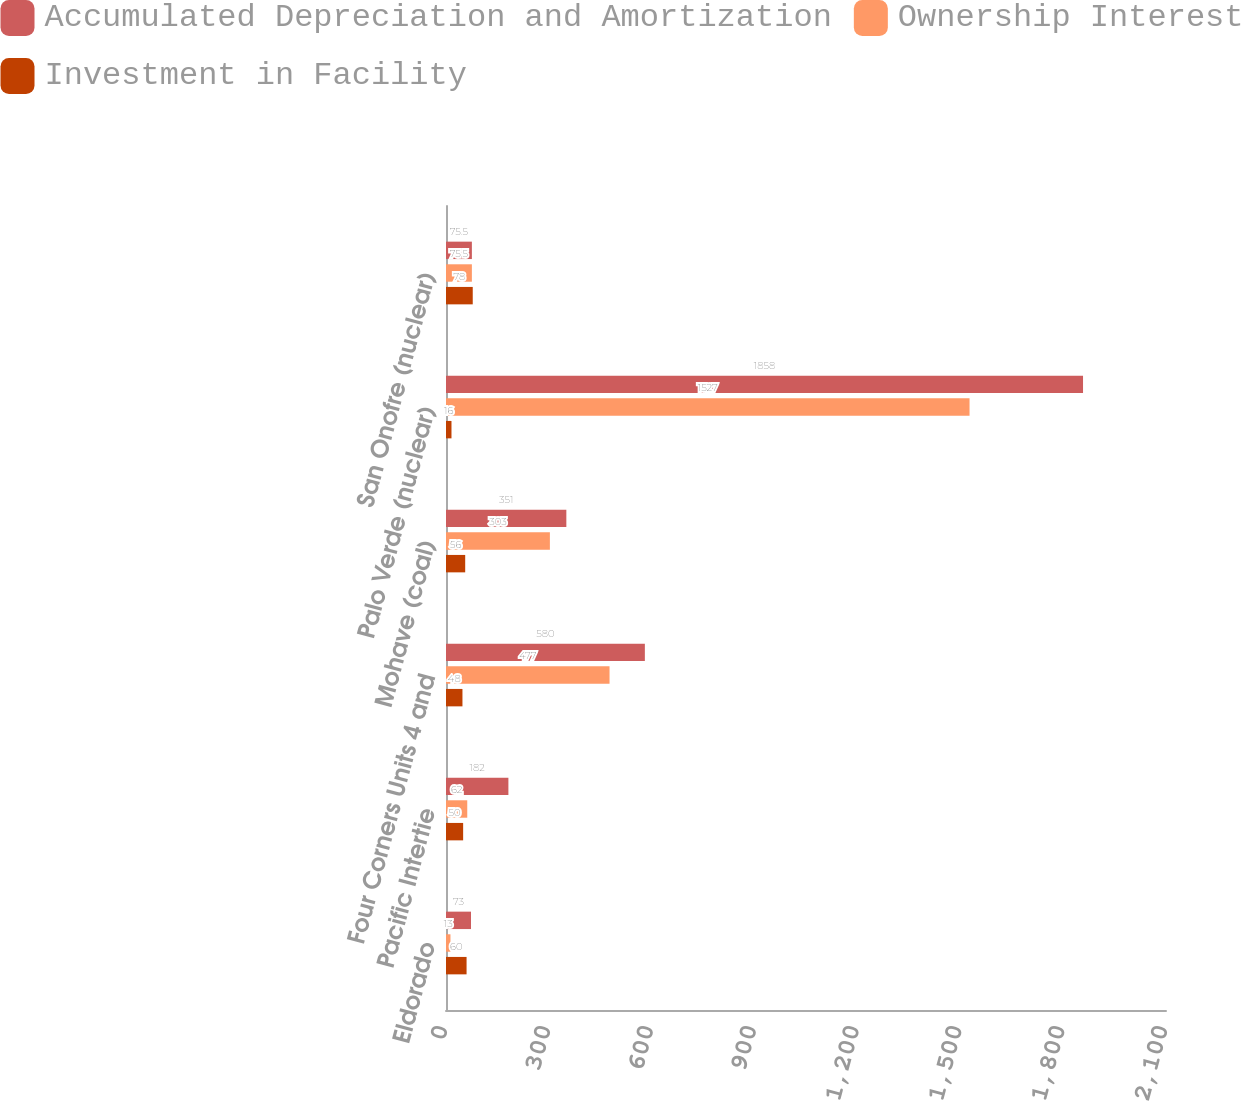Convert chart. <chart><loc_0><loc_0><loc_500><loc_500><stacked_bar_chart><ecel><fcel>Eldorado<fcel>Pacific Intertie<fcel>Four Corners Units 4 and<fcel>Mohave (coal)<fcel>Palo Verde (nuclear)<fcel>San Onofre (nuclear)<nl><fcel>Accumulated Depreciation and Amortization<fcel>73<fcel>182<fcel>580<fcel>351<fcel>1858<fcel>75.5<nl><fcel>Ownership Interest<fcel>13<fcel>62<fcel>477<fcel>303<fcel>1527<fcel>75.5<nl><fcel>Investment in Facility<fcel>60<fcel>50<fcel>48<fcel>56<fcel>16<fcel>78<nl></chart> 